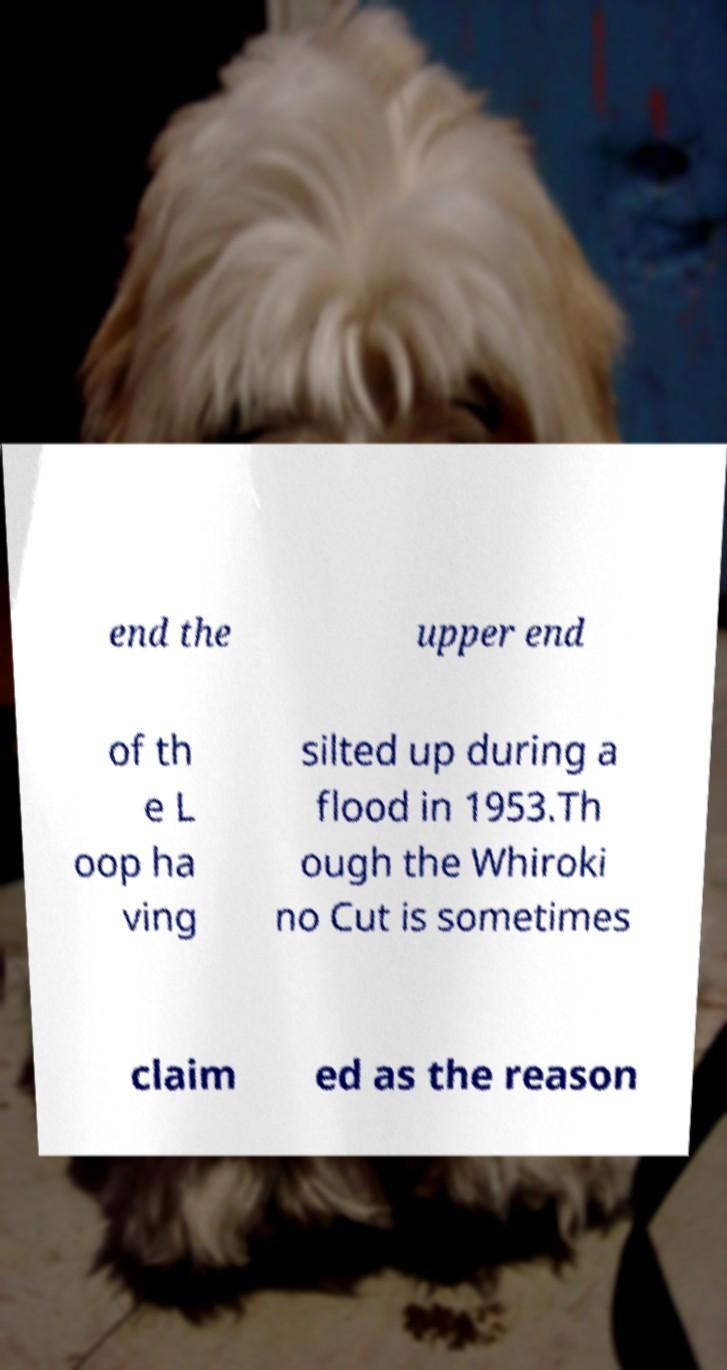There's text embedded in this image that I need extracted. Can you transcribe it verbatim? end the upper end of th e L oop ha ving silted up during a flood in 1953.Th ough the Whiroki no Cut is sometimes claim ed as the reason 